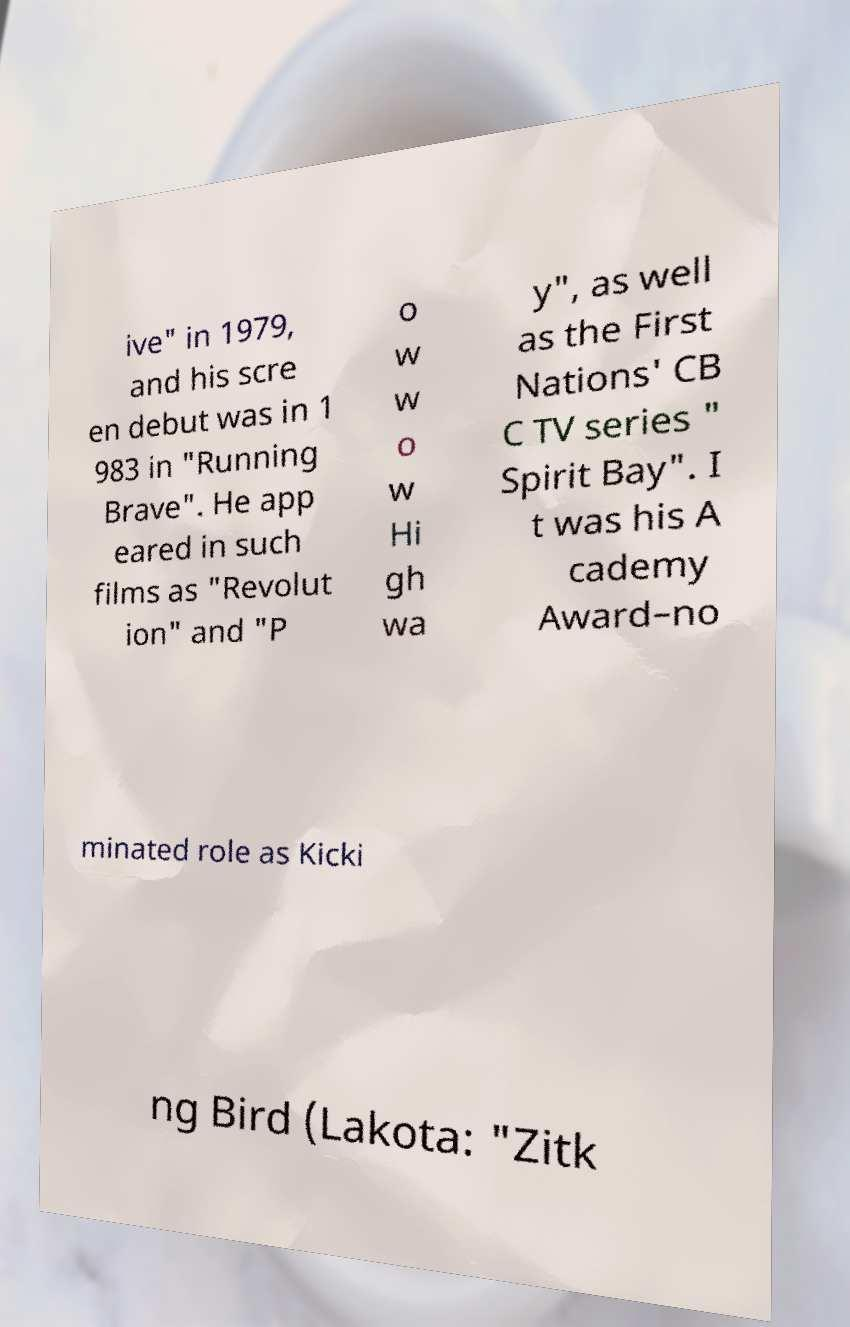Please identify and transcribe the text found in this image. ive" in 1979, and his scre en debut was in 1 983 in "Running Brave". He app eared in such films as "Revolut ion" and "P o w w o w Hi gh wa y", as well as the First Nations' CB C TV series " Spirit Bay". I t was his A cademy Award–no minated role as Kicki ng Bird (Lakota: "Zitk 